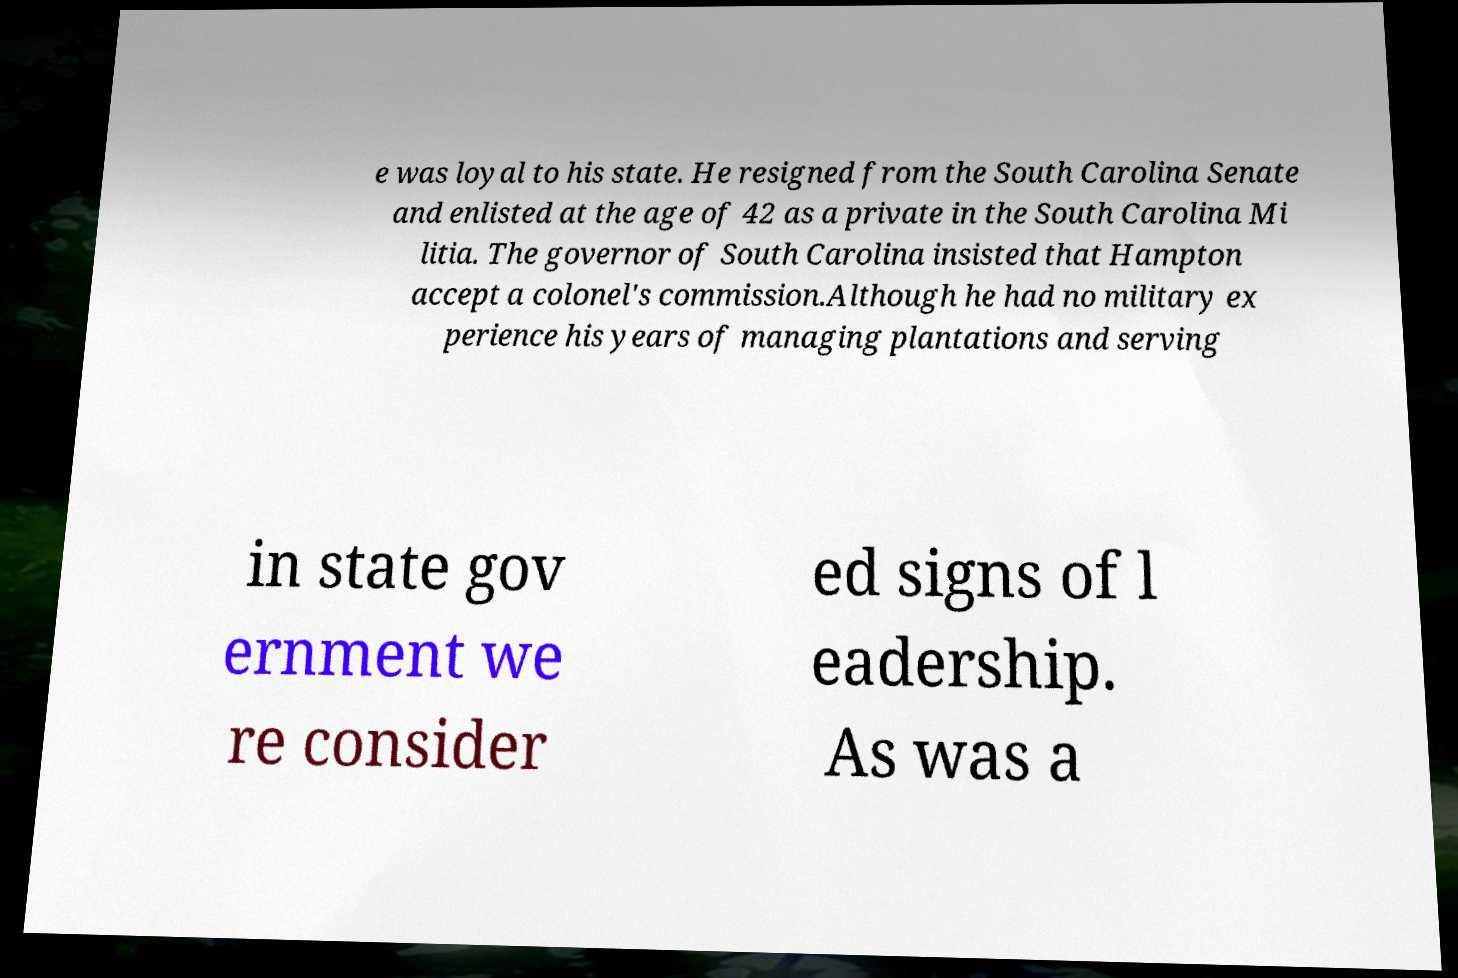Could you assist in decoding the text presented in this image and type it out clearly? e was loyal to his state. He resigned from the South Carolina Senate and enlisted at the age of 42 as a private in the South Carolina Mi litia. The governor of South Carolina insisted that Hampton accept a colonel's commission.Although he had no military ex perience his years of managing plantations and serving in state gov ernment we re consider ed signs of l eadership. As was a 